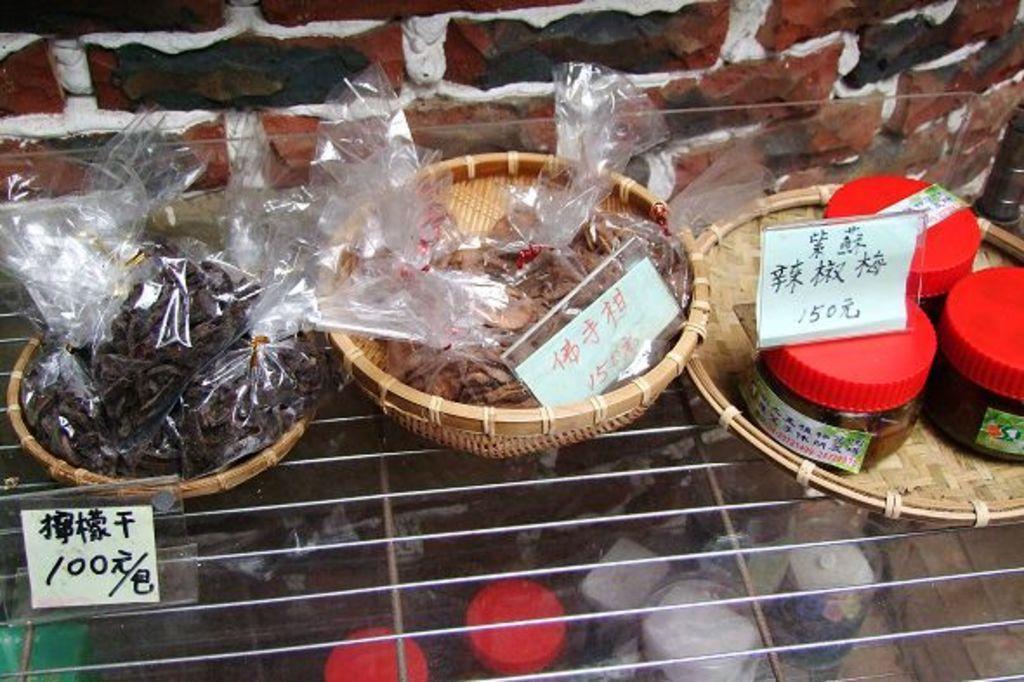In one or two sentences, can you explain what this image depicts? In the image there are few eatables kept on a wooden a plate and wooden bowls, below there is a steel tray and below the tray there are some other objects. 